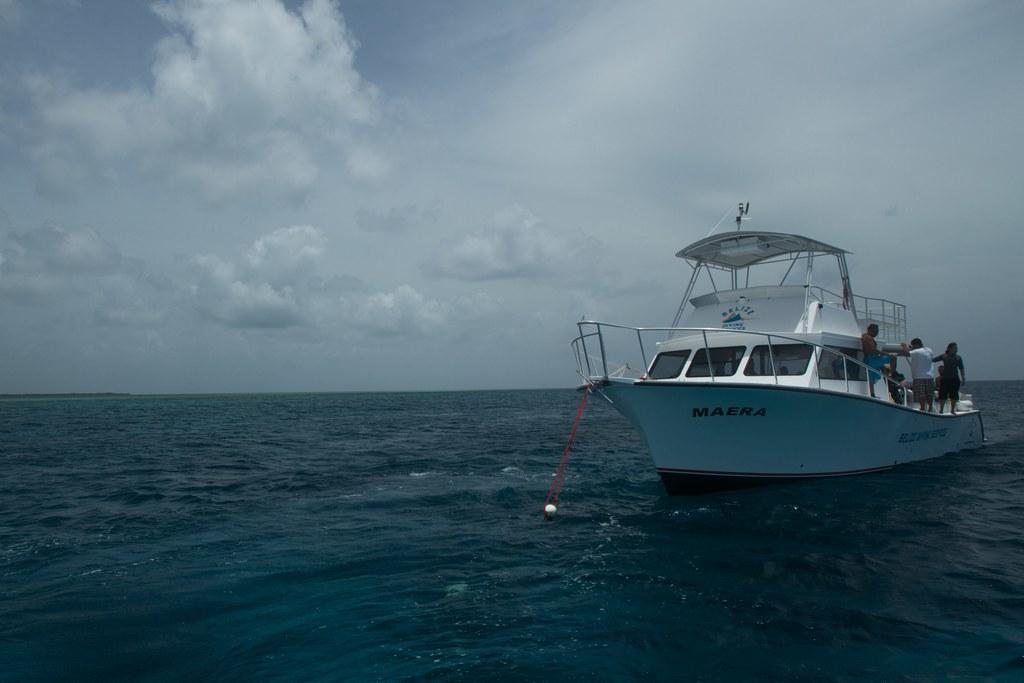What is the main subject of the image? The main subject of the image is water. What can be seen floating on the water? There is a boat in the image. Are there any people present in the image? Yes, there are people in the image. What is visible above the water in the image? The sky is visible in the image. What can be observed in the sky? Clouds are present in the sky. What type of rice can be seen growing near the water in the image? There is no rice present in the image; it features water, a boat, people, and clouds in the sky. How many frogs can be seen hopping around the boat in the image? There are no frogs present in the image; it only features water, a boat, people, and clouds in the sky. 